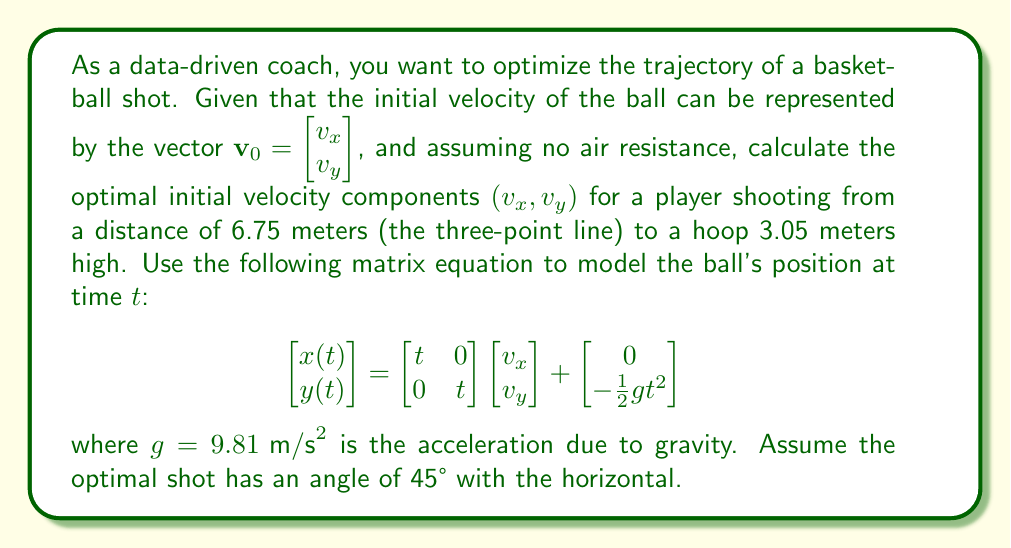Give your solution to this math problem. To solve this problem, we'll follow these steps:

1) First, we know that the optimal shot angle is 45°. This means that $v_x = v_y = v$ for some value $v$.

2) We need to find the time $t$ when the ball reaches the hoop. At this point, $x(t) = 6.75$ and $y(t) = 3.05$.

3) Using the given matrix equation:

   $$\begin{bmatrix} 6.75 \\ 3.05 \end{bmatrix} = \begin{bmatrix} t & 0 \\ 0 & t \end{bmatrix} \begin{bmatrix} v \\ v \end{bmatrix} + \begin{bmatrix} 0 \\ -\frac{1}{2}gt^2 \end{bmatrix}$$

4) This gives us two equations:

   $6.75 = vt$
   $3.05 = vt - \frac{1}{2}gt^2$

5) From the first equation: $t = \frac{6.75}{v}$

6) Substituting this into the second equation:

   $3.05 = 6.75 - \frac{1}{2}g(\frac{6.75}{v})^2$

7) Solving for $v$:

   $3.05 = 6.75 - \frac{1}{2}g\frac{45.5625}{v^2}$
   $3.7 = \frac{1}{2}g\frac{45.5625}{v^2}$
   $v^2 = \frac{1}{2}g\frac{45.5625}{3.7}$
   $v = \sqrt{\frac{1}{2}g\frac{45.5625}{3.7}} \approx 8.57 \text{ m/s}$

8) Therefore, $v_x = v_y = 8.57 \text{ m/s}$

9) We can verify by calculating the time:

   $t = \frac{6.75}{8.57} \approx 0.79 \text{ seconds}$

   And checking the y-coordinate:

   $y(0.79) = 8.57 * 0.79 - \frac{1}{2} * 9.81 * 0.79^2 \approx 3.05 \text{ meters}$

This confirms our calculation.
Answer: The optimal initial velocity components are:

$v_x = v_y \approx 8.57 \text{ m/s}$

Therefore, the optimal initial velocity vector is:

$$\mathbf{v}_0 = \begin{bmatrix} 8.57 \\ 8.57 \end{bmatrix} \text{ m/s}$$ 